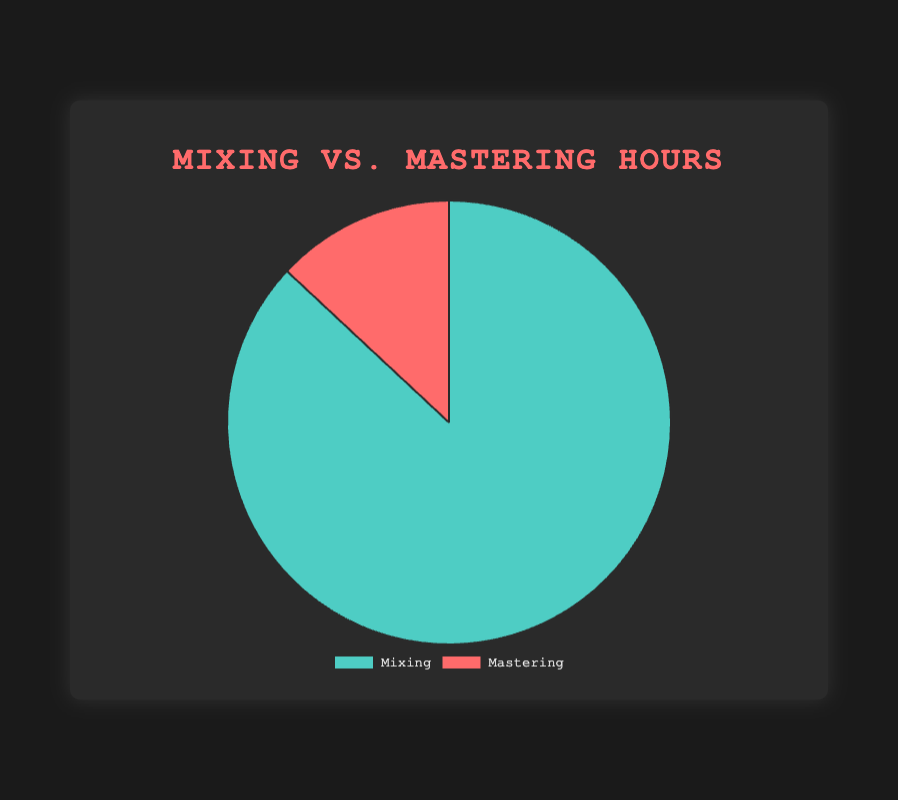What is the total number of hours spent on Mixing? To find the total hours spent on Mixing, sum up the hours from all projects: 120 + 90 + 110 + 95 + 85
Answer: 500 What is the difference in hours between Mixing and Mastering? Mixing hours total up to 500, while Mastering totals 75. Subtracting these gives 500 - 75
Answer: 425 What is the percentage of time spent on Mastering compared to the total hours? Calculate the total hours spent (Mixing + Mastering) which is 500 + 75 = 575. The percentage is (75/575) * 100
Answer: 13.04% Which process took up more hours: Mixing or Mastering? By comparing total hours, Mixing has 500 hours while Mastering has only 75 hours.
Answer: Mixing How does the visual representation of Mixing compare to Mastering in terms of size? The pie chart segment representing Mixing is visually larger than the segment for Mastering, indicating more time was spent on Mixing.
Answer: Mixing is larger What is the ratio of hours spent on Mixing to Mastering? The ratio of Mixing to Mastering hours is calculated as 500:75. Simplifying this ratio gives 20:3
Answer: 20:3 What fraction of the total hours does Mastering represent? The fraction of Mastering hours is 75 out of the total 575 hours, which simplifies to 75/575.
Answer: 3/23 If the hours spent on Mixing were reduced by 100 hours, how would the new total hours compare between Mixing and Mastering? Reducing Mixing hours by 100 gives 500 - 100 = 400 hours. So, Mixing would have 400 hours, Mastering would remain at 75 hours. New total = 400 + 75 = 475
Answer: Mixing: 400, Total: 475 How many more hours were spent on the project with the most Mixing hours compared to the least? The project with the most Mixing hours is Converge - Jane Doe with 120 hours, and the least is Torche - Harmonicraft with 85 hours. The difference is 120 - 85
Answer: 35 What percentage of total hours for the project with the least Mastering time was spent on Mixing? For Napalm Death - Apex Predator – Easy Meat, the Mixing hours are 110 and the Mastering hours are 10. Total hours for this project are 110 + 10 = 120. The percentage is (110/120) * 100
Answer: 91.67% 